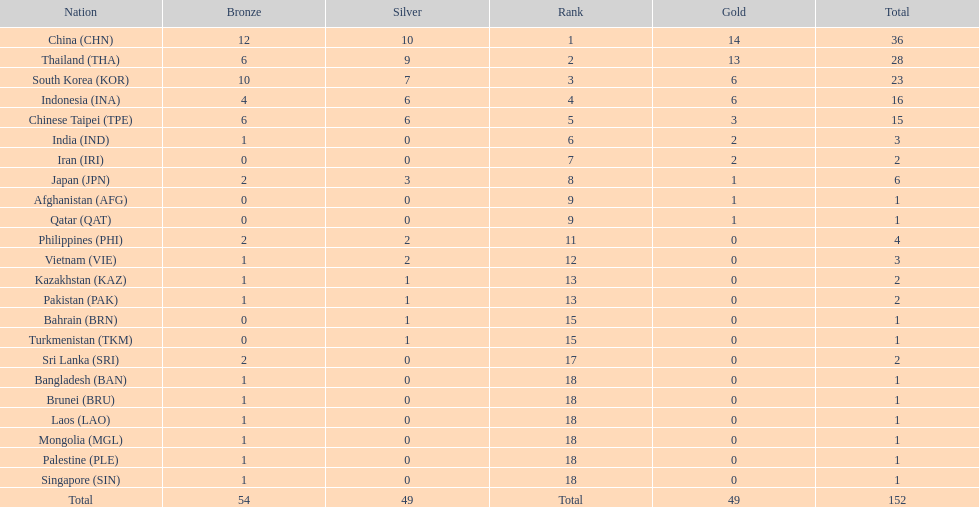What was the number of medals earned by indonesia (ina) ? 16. 